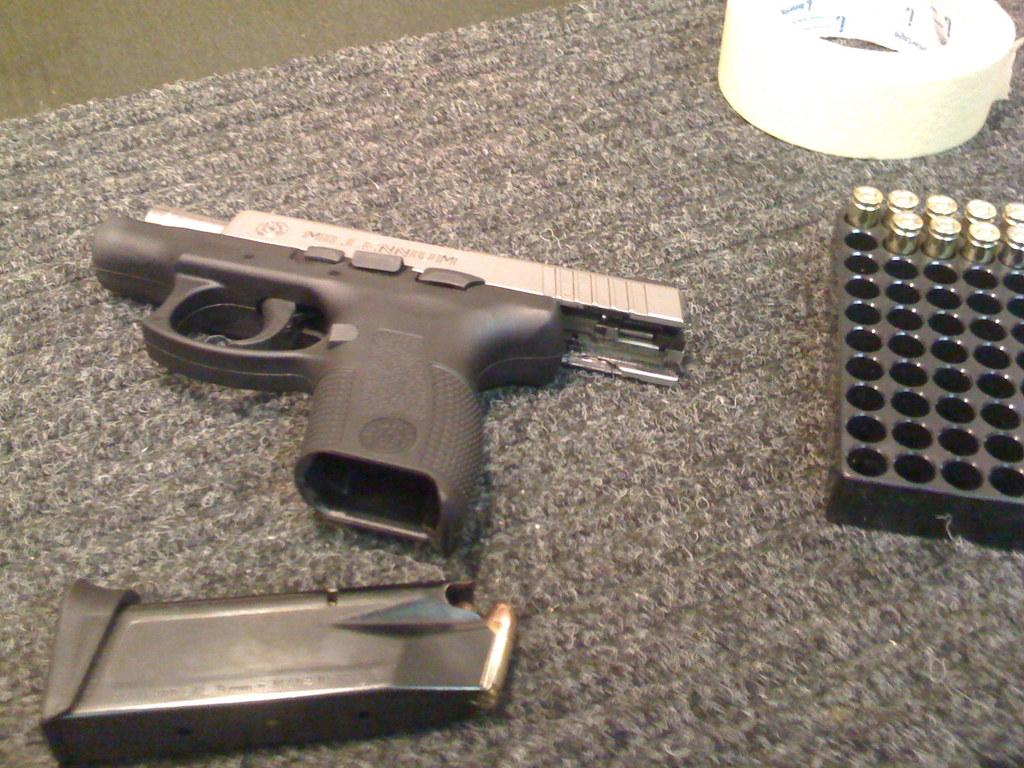What type of weapon is present in the image? There is a gun in the image. What else can be seen in the image besides the gun? There is a plaster and bullets in the image. What is the color of the cloth at the bottom of the image? The cloth at the bottom of the image is grey. What brand of toothpaste is being advertised on the gun in the image? There is no toothpaste or advertisement present in the image. Can you tell me how many shoes are visible in the image? There are no shoes visible in the image. 